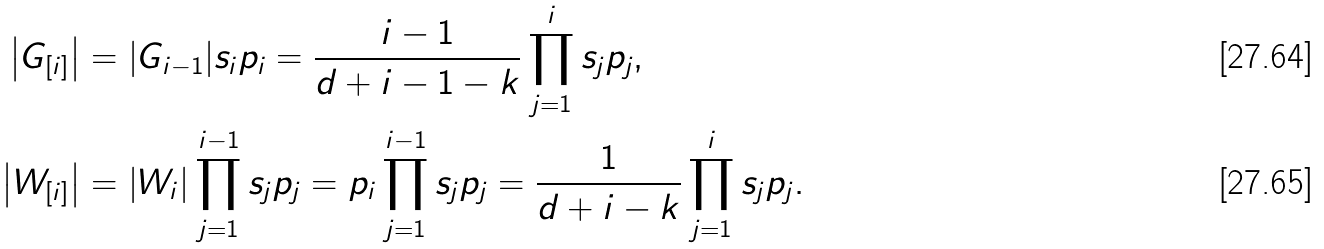<formula> <loc_0><loc_0><loc_500><loc_500>\left | G _ { [ i ] } \right | & = | G _ { i - 1 } | s _ { i } p _ { i } = \frac { i - 1 } { d + i - 1 - k } \prod _ { j = 1 } ^ { i } s _ { j } p _ { j } , \\ \left | W _ { [ i ] } \right | & = | W _ { i } | \prod _ { j = 1 } ^ { i - 1 } s _ { j } p _ { j } = p _ { i } \prod _ { j = 1 } ^ { i - 1 } s _ { j } p _ { j } = \frac { 1 } { d + i - k } \prod _ { j = 1 } ^ { i } s _ { j } p _ { j } .</formula> 